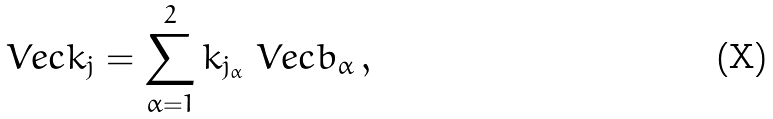Convert formula to latex. <formula><loc_0><loc_0><loc_500><loc_500>\ V e c { k } _ { j } = \sum _ { \alpha = 1 } ^ { 2 } k _ { j _ { \alpha } } \ V e c { b } _ { \alpha } \, ,</formula> 